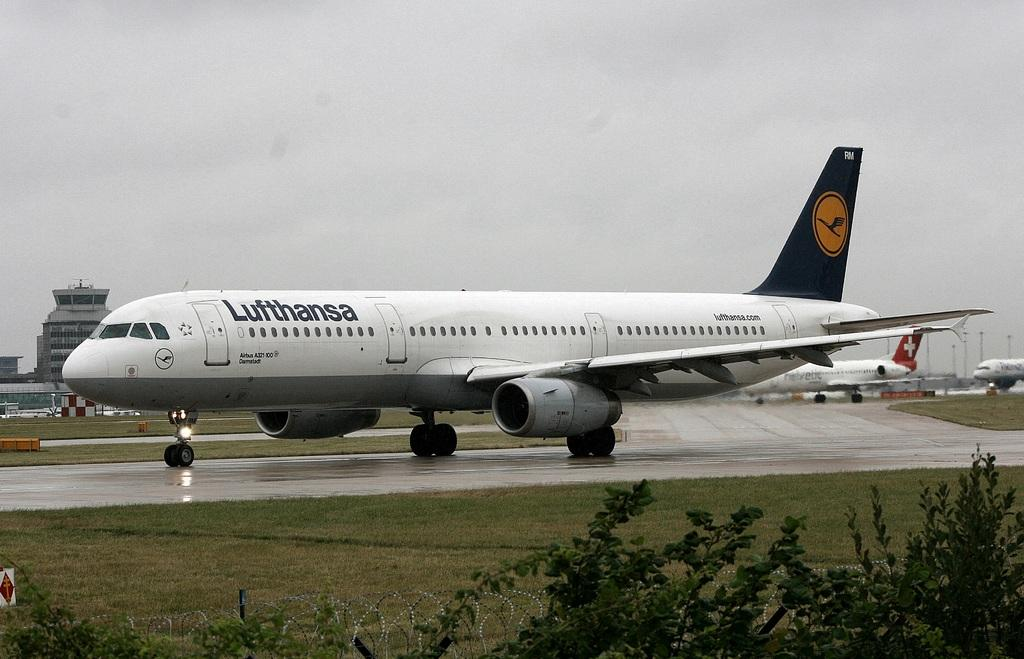<image>
Summarize the visual content of the image. a plane on a runway owned by Lufthansa on it 